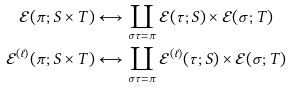<formula> <loc_0><loc_0><loc_500><loc_500>\mathcal { E } ( \pi ; S \times T ) & \longleftrightarrow \coprod _ { \sigma \tau = \pi } \mathcal { E } ( \tau ; S ) \times \mathcal { E } ( \sigma ; T ) \\ \mathcal { E } ^ { ( \ell ) } ( \pi ; S \times T ) & \longleftrightarrow \coprod _ { \sigma \tau = \pi } \mathcal { E } ^ { ( \ell ) } ( \tau ; S ) \times \mathcal { E } ( \sigma ; T )</formula> 